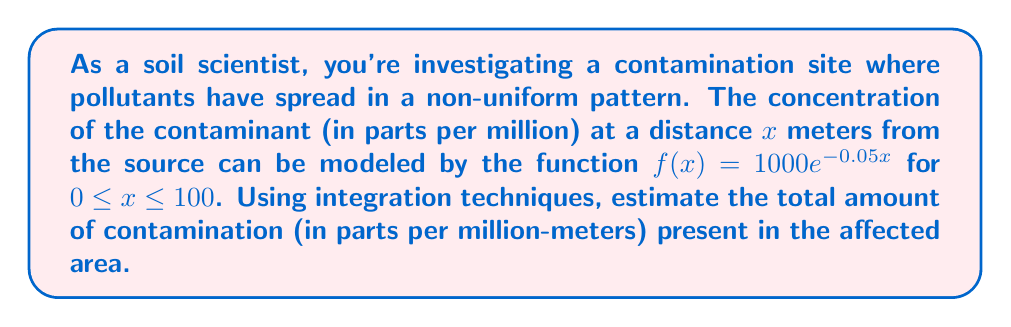Teach me how to tackle this problem. To estimate the total amount of contamination, we need to calculate the area under the curve described by the function $f(x) = 1000e^{-0.05x}$ from $x = 0$ to $x = 100$. This can be done using definite integration.

Step 1: Set up the definite integral
$$\int_0^{100} 1000e^{-0.05x} dx$$

Step 2: Factor out the constant
$$1000 \int_0^{100} e^{-0.05x} dx$$

Step 3: Use the integration rule for exponential functions
$$\int e^{ax} dx = \frac{1}{a}e^{ax} + C$$

In our case, $a = -0.05$, so:
$$1000 \left[-\frac{1}{0.05}e^{-0.05x}\right]_0^{100}$$

Step 4: Evaluate the integral at the limits
$$1000 \left(-\frac{1}{0.05}\right) \left(e^{-0.05(100)} - e^{-0.05(0)}\right)$$

Step 5: Simplify
$$1000 \left(-\frac{1}{0.05}\right) \left(e^{-5} - 1\right)$$
$$-20000 \left(e^{-5} - 1\right)$$
$$-20000 (0.00673795 - 1)$$
$$-20000 (-0.99326205)$$
$$19865.241$$

Therefore, the total amount of contamination is approximately 19,865.241 parts per million-meters.
Answer: 19,865.241 ppm-m 